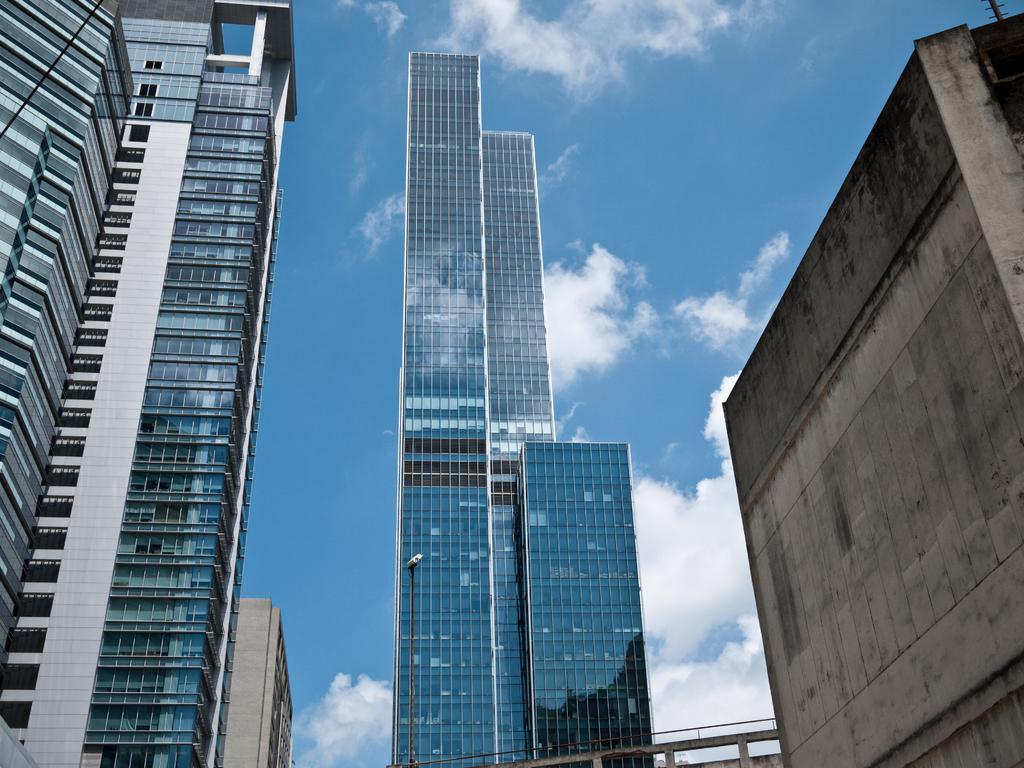Could you give a brief overview of what you see in this image? In this image there are huge buildings on either side and in middle there is a big building with glasses, in the background there is blue sky. 